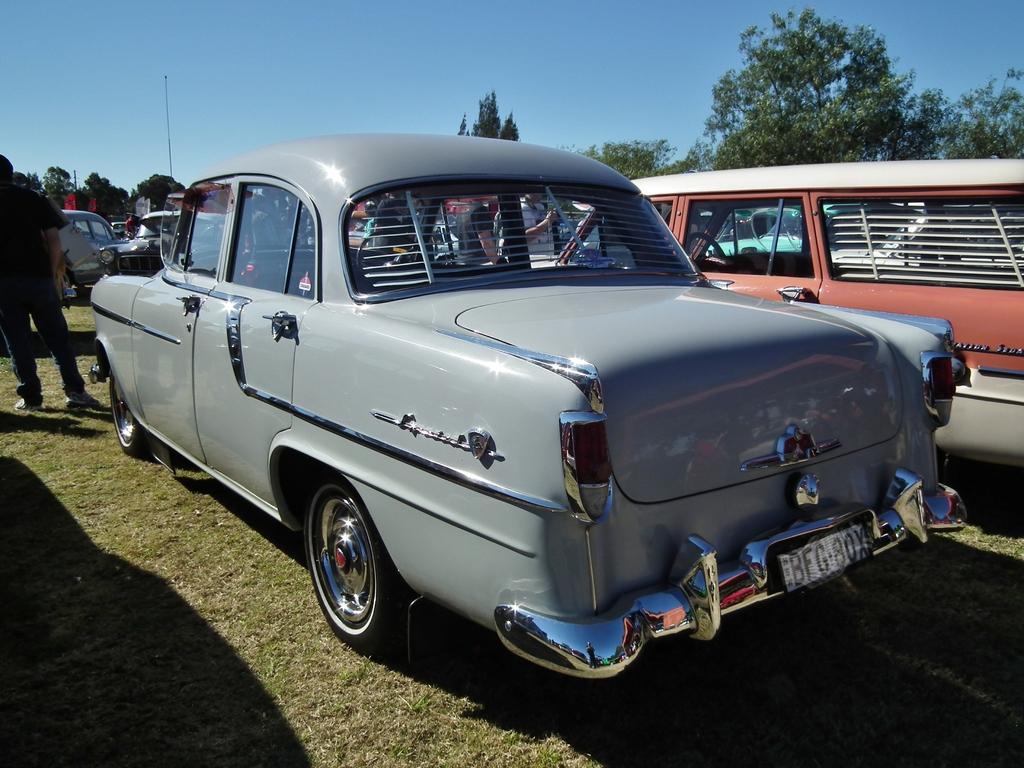Can you describe this image briefly? This is the picture of a place where we have some cars on the grass floor and around there are some people, trees and a pole. 